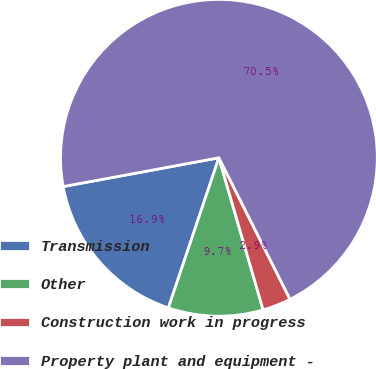Convert chart to OTSL. <chart><loc_0><loc_0><loc_500><loc_500><pie_chart><fcel>Transmission<fcel>Other<fcel>Construction work in progress<fcel>Property plant and equipment -<nl><fcel>16.92%<fcel>9.67%<fcel>2.91%<fcel>70.49%<nl></chart> 